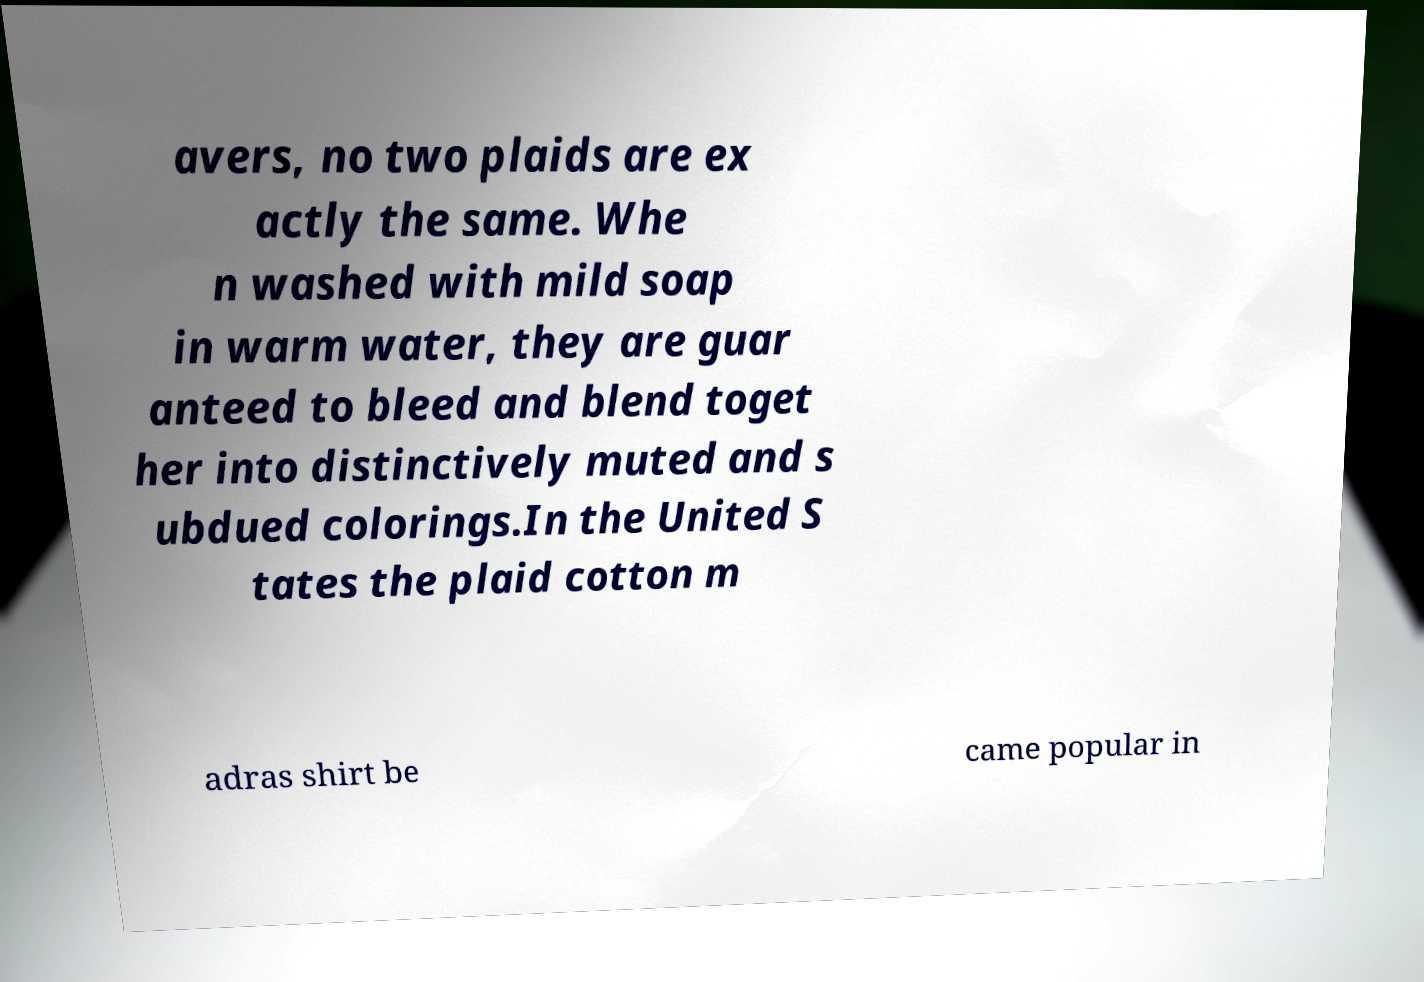Can you read and provide the text displayed in the image?This photo seems to have some interesting text. Can you extract and type it out for me? avers, no two plaids are ex actly the same. Whe n washed with mild soap in warm water, they are guar anteed to bleed and blend toget her into distinctively muted and s ubdued colorings.In the United S tates the plaid cotton m adras shirt be came popular in 